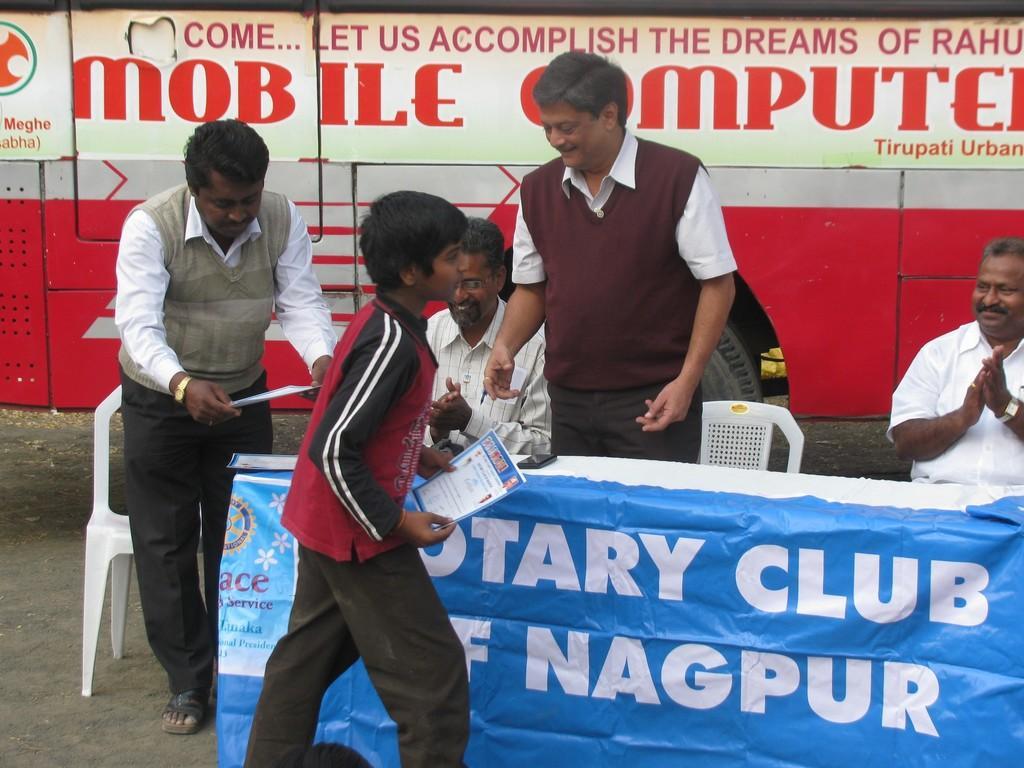Could you give a brief overview of what you see in this image? There is a kid standing and holding a certificate in his hands and there are four persons beside him and there is a vehicle which has something written on it in the background. 